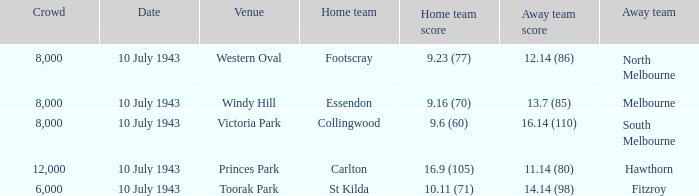Write the full table. {'header': ['Crowd', 'Date', 'Venue', 'Home team', 'Home team score', 'Away team score', 'Away team'], 'rows': [['8,000', '10 July 1943', 'Western Oval', 'Footscray', '9.23 (77)', '12.14 (86)', 'North Melbourne'], ['8,000', '10 July 1943', 'Windy Hill', 'Essendon', '9.16 (70)', '13.7 (85)', 'Melbourne'], ['8,000', '10 July 1943', 'Victoria Park', 'Collingwood', '9.6 (60)', '16.14 (110)', 'South Melbourne'], ['12,000', '10 July 1943', 'Princes Park', 'Carlton', '16.9 (105)', '11.14 (80)', 'Hawthorn'], ['6,000', '10 July 1943', 'Toorak Park', 'St Kilda', '10.11 (71)', '14.14 (98)', 'Fitzroy']]} When the Home team of carlton played, what was their score? 16.9 (105). 